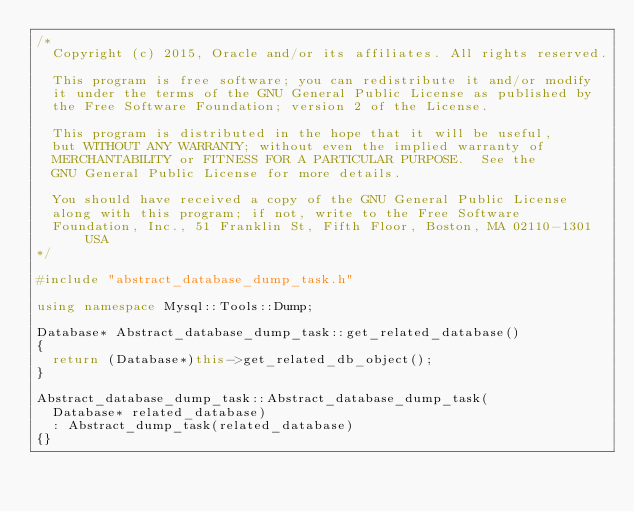<code> <loc_0><loc_0><loc_500><loc_500><_C++_>/*
  Copyright (c) 2015, Oracle and/or its affiliates. All rights reserved.

  This program is free software; you can redistribute it and/or modify
  it under the terms of the GNU General Public License as published by
  the Free Software Foundation; version 2 of the License.

  This program is distributed in the hope that it will be useful,
  but WITHOUT ANY WARRANTY; without even the implied warranty of
  MERCHANTABILITY or FITNESS FOR A PARTICULAR PURPOSE.  See the
  GNU General Public License for more details.

  You should have received a copy of the GNU General Public License
  along with this program; if not, write to the Free Software
  Foundation, Inc., 51 Franklin St, Fifth Floor, Boston, MA 02110-1301  USA
*/

#include "abstract_database_dump_task.h"

using namespace Mysql::Tools::Dump;

Database* Abstract_database_dump_task::get_related_database()
{
  return (Database*)this->get_related_db_object();
}

Abstract_database_dump_task::Abstract_database_dump_task(
  Database* related_database)
  : Abstract_dump_task(related_database)
{}
 </code> 